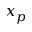<formula> <loc_0><loc_0><loc_500><loc_500>x _ { p }</formula> 